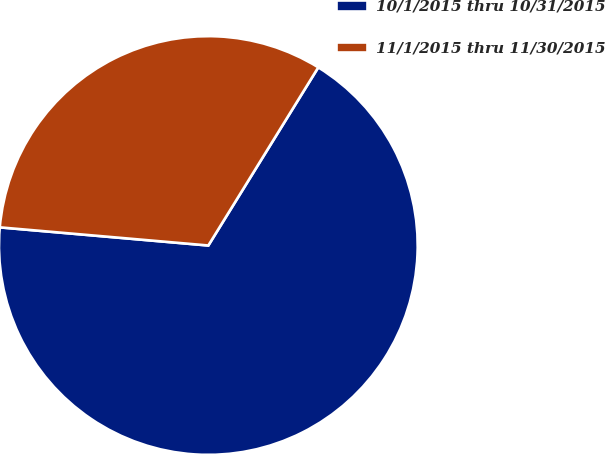Convert chart to OTSL. <chart><loc_0><loc_0><loc_500><loc_500><pie_chart><fcel>10/1/2015 thru 10/31/2015<fcel>11/1/2015 thru 11/30/2015<nl><fcel>67.58%<fcel>32.42%<nl></chart> 